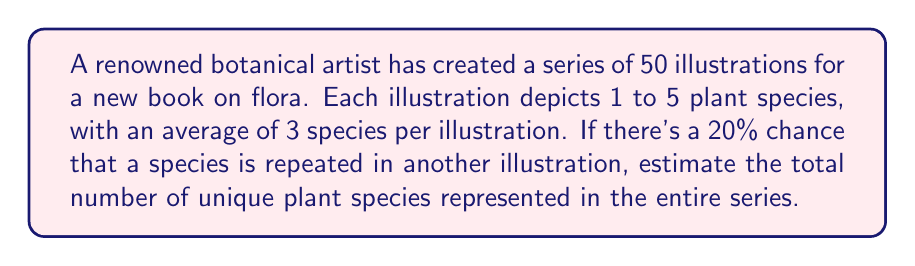Show me your answer to this math problem. Let's approach this step-by-step:

1) First, let's calculate the total number of plant species depicted:
   $50 \text{ illustrations} \times 3 \text{ species per illustration} = 150 \text{ total species}$

2) Now, we need to account for repetitions. We're told there's a 20% chance of repetition, which means 80% of the species are likely unique.

3) To calculate the number of unique species, we multiply the total by the probability of uniqueness:
   $150 \times 0.80 = 120$

4) However, this is a simplification. In reality, the probability of a species being unique decreases slightly with each new illustration, as there are more opportunities for repetition.

5) To account for this, we can apply a small correction factor. A common approach is to use the formula:
   $$N = n(1 - e^{-n/N})$$
   Where $N$ is the estimated number of unique species, $n$ is the total number of observations (150 in our case), and $N$ is what we're solving for.

6) This equation doesn't have a closed-form solution, but we can approximate $N$ as slightly less than our initial estimate of 120.

7) Given the level of precision appropriate for this estimate, we can reasonably round down to 115 unique species.
Answer: Approximately 115 unique plant species 